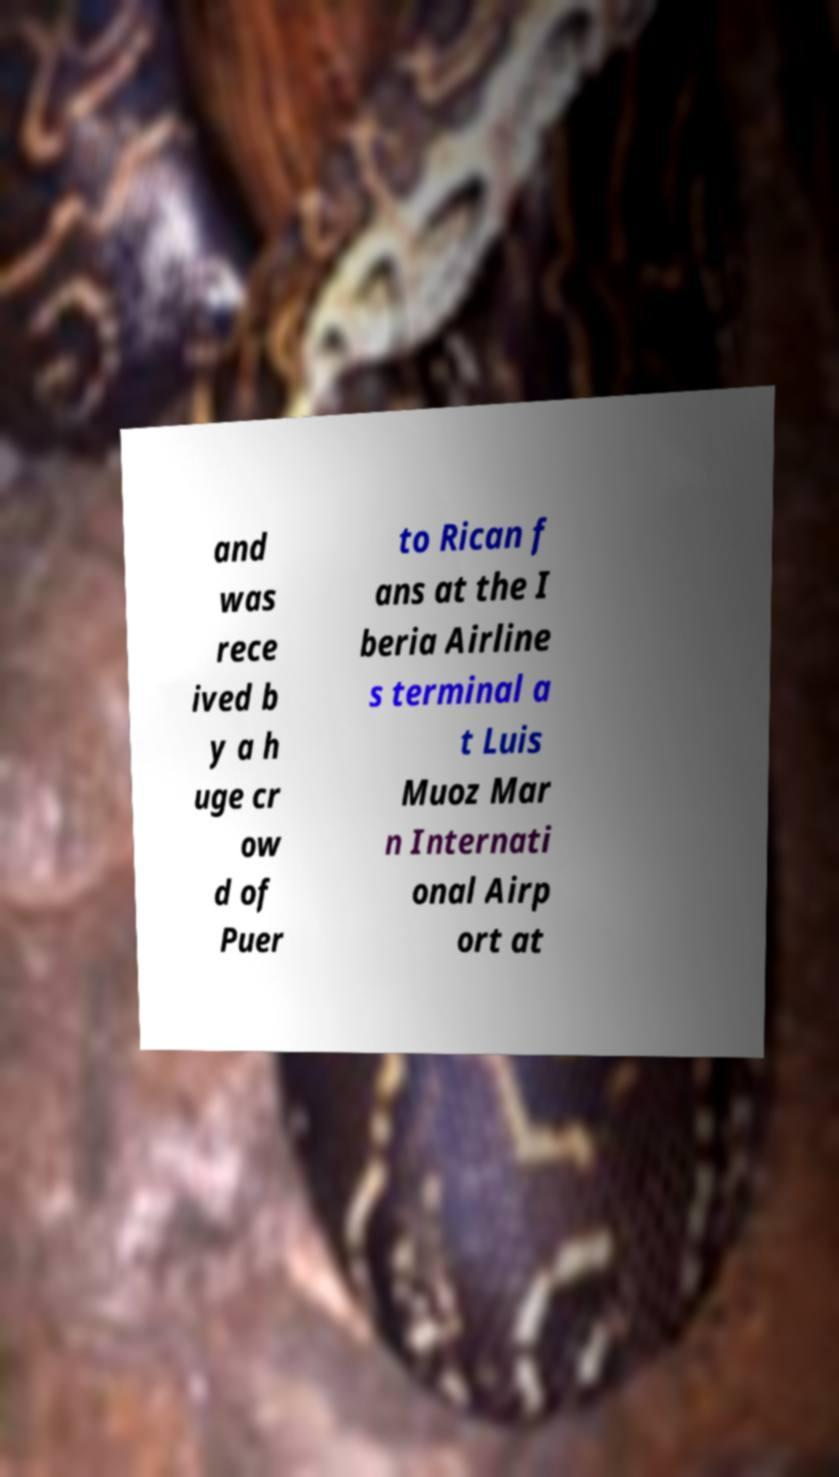Can you read and provide the text displayed in the image?This photo seems to have some interesting text. Can you extract and type it out for me? and was rece ived b y a h uge cr ow d of Puer to Rican f ans at the I beria Airline s terminal a t Luis Muoz Mar n Internati onal Airp ort at 